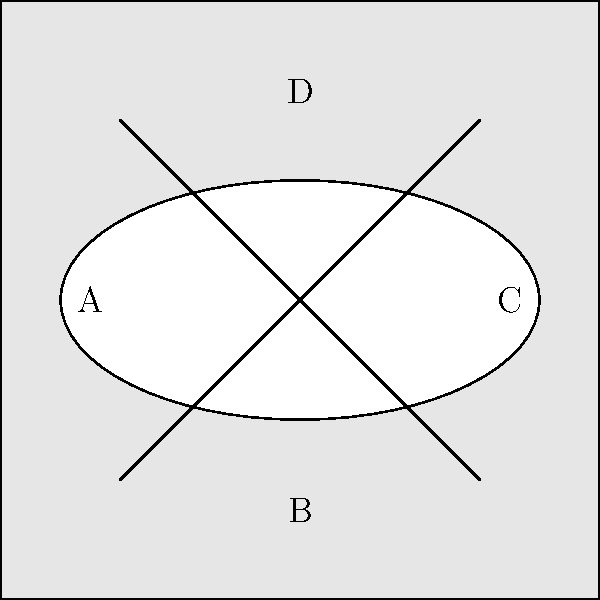The diagram represents a cross-section of a complex geological formation. If a horizontal drill were to pass through this formation from left to right at the level of the ellipse's center, in what order would it encounter the different regions (labeled A, B, C, and D)? To solve this problem, we need to analyze the cross-section from left to right at the level of the ellipse's center:

1. The drill starts on the left side of the formation.
2. It first encounters region A, which is the outer layer on the left.
3. Next, it enters the elliptical region in the center.
4. The drill then passes through the intersection of the two diagonal lines within the ellipse.
5. Finally, it exits the ellipse and enters region C on the right side.

Note that the drill does not pass through regions B or D, as these are above and below the horizontal line passing through the ellipse's center.

Therefore, the order of regions encountered is: A, ellipse interior, C.
Answer: A, ellipse interior, C 